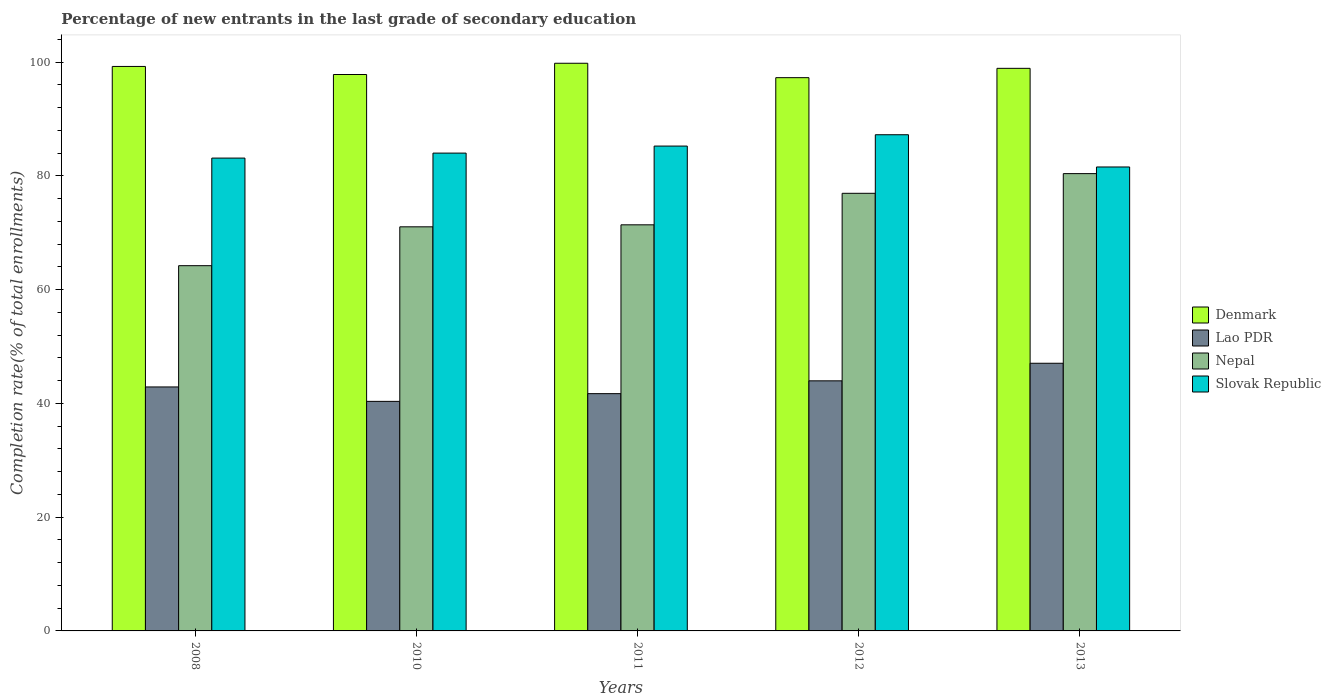How many groups of bars are there?
Make the answer very short. 5. Are the number of bars on each tick of the X-axis equal?
Provide a succinct answer. Yes. What is the label of the 4th group of bars from the left?
Make the answer very short. 2012. In how many cases, is the number of bars for a given year not equal to the number of legend labels?
Give a very brief answer. 0. What is the percentage of new entrants in Slovak Republic in 2010?
Ensure brevity in your answer.  84. Across all years, what is the maximum percentage of new entrants in Lao PDR?
Provide a succinct answer. 47.06. Across all years, what is the minimum percentage of new entrants in Denmark?
Your answer should be very brief. 97.26. In which year was the percentage of new entrants in Slovak Republic minimum?
Offer a terse response. 2013. What is the total percentage of new entrants in Lao PDR in the graph?
Offer a very short reply. 215.98. What is the difference between the percentage of new entrants in Lao PDR in 2012 and that in 2013?
Make the answer very short. -3.09. What is the difference between the percentage of new entrants in Nepal in 2011 and the percentage of new entrants in Slovak Republic in 2013?
Keep it short and to the point. -10.17. What is the average percentage of new entrants in Slovak Republic per year?
Your answer should be compact. 84.23. In the year 2010, what is the difference between the percentage of new entrants in Denmark and percentage of new entrants in Lao PDR?
Your answer should be very brief. 57.46. In how many years, is the percentage of new entrants in Lao PDR greater than 24 %?
Keep it short and to the point. 5. What is the ratio of the percentage of new entrants in Denmark in 2010 to that in 2012?
Make the answer very short. 1.01. Is the percentage of new entrants in Slovak Republic in 2010 less than that in 2011?
Your answer should be very brief. Yes. What is the difference between the highest and the second highest percentage of new entrants in Denmark?
Keep it short and to the point. 0.56. What is the difference between the highest and the lowest percentage of new entrants in Lao PDR?
Provide a short and direct response. 6.7. In how many years, is the percentage of new entrants in Nepal greater than the average percentage of new entrants in Nepal taken over all years?
Your response must be concise. 2. Is it the case that in every year, the sum of the percentage of new entrants in Nepal and percentage of new entrants in Denmark is greater than the sum of percentage of new entrants in Lao PDR and percentage of new entrants in Slovak Republic?
Ensure brevity in your answer.  Yes. What does the 4th bar from the left in 2011 represents?
Keep it short and to the point. Slovak Republic. What is the difference between two consecutive major ticks on the Y-axis?
Keep it short and to the point. 20. Does the graph contain any zero values?
Give a very brief answer. No. What is the title of the graph?
Your answer should be very brief. Percentage of new entrants in the last grade of secondary education. What is the label or title of the Y-axis?
Your answer should be compact. Completion rate(% of total enrollments). What is the Completion rate(% of total enrollments) in Denmark in 2008?
Ensure brevity in your answer.  99.23. What is the Completion rate(% of total enrollments) in Lao PDR in 2008?
Ensure brevity in your answer.  42.89. What is the Completion rate(% of total enrollments) of Nepal in 2008?
Offer a very short reply. 64.21. What is the Completion rate(% of total enrollments) in Slovak Republic in 2008?
Your response must be concise. 83.12. What is the Completion rate(% of total enrollments) in Denmark in 2010?
Your answer should be compact. 97.81. What is the Completion rate(% of total enrollments) of Lao PDR in 2010?
Offer a terse response. 40.36. What is the Completion rate(% of total enrollments) of Nepal in 2010?
Give a very brief answer. 71.04. What is the Completion rate(% of total enrollments) of Slovak Republic in 2010?
Your answer should be very brief. 84. What is the Completion rate(% of total enrollments) of Denmark in 2011?
Keep it short and to the point. 99.79. What is the Completion rate(% of total enrollments) of Lao PDR in 2011?
Provide a succinct answer. 41.71. What is the Completion rate(% of total enrollments) in Nepal in 2011?
Keep it short and to the point. 71.39. What is the Completion rate(% of total enrollments) of Slovak Republic in 2011?
Keep it short and to the point. 85.23. What is the Completion rate(% of total enrollments) of Denmark in 2012?
Your answer should be very brief. 97.26. What is the Completion rate(% of total enrollments) of Lao PDR in 2012?
Make the answer very short. 43.96. What is the Completion rate(% of total enrollments) in Nepal in 2012?
Give a very brief answer. 76.93. What is the Completion rate(% of total enrollments) of Slovak Republic in 2012?
Keep it short and to the point. 87.23. What is the Completion rate(% of total enrollments) of Denmark in 2013?
Make the answer very short. 98.9. What is the Completion rate(% of total enrollments) in Lao PDR in 2013?
Keep it short and to the point. 47.06. What is the Completion rate(% of total enrollments) in Nepal in 2013?
Your answer should be compact. 80.39. What is the Completion rate(% of total enrollments) in Slovak Republic in 2013?
Provide a short and direct response. 81.56. Across all years, what is the maximum Completion rate(% of total enrollments) of Denmark?
Your answer should be very brief. 99.79. Across all years, what is the maximum Completion rate(% of total enrollments) of Lao PDR?
Provide a succinct answer. 47.06. Across all years, what is the maximum Completion rate(% of total enrollments) in Nepal?
Provide a succinct answer. 80.39. Across all years, what is the maximum Completion rate(% of total enrollments) of Slovak Republic?
Your answer should be very brief. 87.23. Across all years, what is the minimum Completion rate(% of total enrollments) of Denmark?
Provide a succinct answer. 97.26. Across all years, what is the minimum Completion rate(% of total enrollments) of Lao PDR?
Provide a short and direct response. 40.36. Across all years, what is the minimum Completion rate(% of total enrollments) in Nepal?
Provide a succinct answer. 64.21. Across all years, what is the minimum Completion rate(% of total enrollments) of Slovak Republic?
Offer a terse response. 81.56. What is the total Completion rate(% of total enrollments) in Denmark in the graph?
Your answer should be compact. 493. What is the total Completion rate(% of total enrollments) of Lao PDR in the graph?
Provide a succinct answer. 215.98. What is the total Completion rate(% of total enrollments) of Nepal in the graph?
Ensure brevity in your answer.  363.96. What is the total Completion rate(% of total enrollments) in Slovak Republic in the graph?
Make the answer very short. 421.14. What is the difference between the Completion rate(% of total enrollments) in Denmark in 2008 and that in 2010?
Provide a succinct answer. 1.42. What is the difference between the Completion rate(% of total enrollments) of Lao PDR in 2008 and that in 2010?
Keep it short and to the point. 2.54. What is the difference between the Completion rate(% of total enrollments) in Nepal in 2008 and that in 2010?
Ensure brevity in your answer.  -6.83. What is the difference between the Completion rate(% of total enrollments) in Slovak Republic in 2008 and that in 2010?
Give a very brief answer. -0.88. What is the difference between the Completion rate(% of total enrollments) of Denmark in 2008 and that in 2011?
Ensure brevity in your answer.  -0.56. What is the difference between the Completion rate(% of total enrollments) in Lao PDR in 2008 and that in 2011?
Your response must be concise. 1.18. What is the difference between the Completion rate(% of total enrollments) of Nepal in 2008 and that in 2011?
Offer a very short reply. -7.18. What is the difference between the Completion rate(% of total enrollments) in Slovak Republic in 2008 and that in 2011?
Offer a terse response. -2.11. What is the difference between the Completion rate(% of total enrollments) in Denmark in 2008 and that in 2012?
Offer a terse response. 1.97. What is the difference between the Completion rate(% of total enrollments) of Lao PDR in 2008 and that in 2012?
Give a very brief answer. -1.07. What is the difference between the Completion rate(% of total enrollments) of Nepal in 2008 and that in 2012?
Offer a terse response. -12.72. What is the difference between the Completion rate(% of total enrollments) in Slovak Republic in 2008 and that in 2012?
Offer a terse response. -4.11. What is the difference between the Completion rate(% of total enrollments) in Denmark in 2008 and that in 2013?
Ensure brevity in your answer.  0.33. What is the difference between the Completion rate(% of total enrollments) of Lao PDR in 2008 and that in 2013?
Offer a terse response. -4.17. What is the difference between the Completion rate(% of total enrollments) of Nepal in 2008 and that in 2013?
Give a very brief answer. -16.19. What is the difference between the Completion rate(% of total enrollments) of Slovak Republic in 2008 and that in 2013?
Your response must be concise. 1.56. What is the difference between the Completion rate(% of total enrollments) of Denmark in 2010 and that in 2011?
Provide a short and direct response. -1.98. What is the difference between the Completion rate(% of total enrollments) in Lao PDR in 2010 and that in 2011?
Make the answer very short. -1.36. What is the difference between the Completion rate(% of total enrollments) in Nepal in 2010 and that in 2011?
Offer a very short reply. -0.35. What is the difference between the Completion rate(% of total enrollments) in Slovak Republic in 2010 and that in 2011?
Keep it short and to the point. -1.24. What is the difference between the Completion rate(% of total enrollments) of Denmark in 2010 and that in 2012?
Offer a very short reply. 0.55. What is the difference between the Completion rate(% of total enrollments) of Lao PDR in 2010 and that in 2012?
Give a very brief answer. -3.61. What is the difference between the Completion rate(% of total enrollments) in Nepal in 2010 and that in 2012?
Offer a very short reply. -5.89. What is the difference between the Completion rate(% of total enrollments) of Slovak Republic in 2010 and that in 2012?
Your answer should be very brief. -3.23. What is the difference between the Completion rate(% of total enrollments) of Denmark in 2010 and that in 2013?
Give a very brief answer. -1.09. What is the difference between the Completion rate(% of total enrollments) in Lao PDR in 2010 and that in 2013?
Keep it short and to the point. -6.7. What is the difference between the Completion rate(% of total enrollments) of Nepal in 2010 and that in 2013?
Offer a very short reply. -9.35. What is the difference between the Completion rate(% of total enrollments) of Slovak Republic in 2010 and that in 2013?
Your answer should be compact. 2.44. What is the difference between the Completion rate(% of total enrollments) in Denmark in 2011 and that in 2012?
Your response must be concise. 2.53. What is the difference between the Completion rate(% of total enrollments) in Lao PDR in 2011 and that in 2012?
Give a very brief answer. -2.25. What is the difference between the Completion rate(% of total enrollments) of Nepal in 2011 and that in 2012?
Offer a terse response. -5.54. What is the difference between the Completion rate(% of total enrollments) in Slovak Republic in 2011 and that in 2012?
Offer a very short reply. -1.99. What is the difference between the Completion rate(% of total enrollments) of Denmark in 2011 and that in 2013?
Give a very brief answer. 0.89. What is the difference between the Completion rate(% of total enrollments) of Lao PDR in 2011 and that in 2013?
Give a very brief answer. -5.34. What is the difference between the Completion rate(% of total enrollments) in Nepal in 2011 and that in 2013?
Your answer should be very brief. -9. What is the difference between the Completion rate(% of total enrollments) of Slovak Republic in 2011 and that in 2013?
Your answer should be compact. 3.67. What is the difference between the Completion rate(% of total enrollments) of Denmark in 2012 and that in 2013?
Your response must be concise. -1.64. What is the difference between the Completion rate(% of total enrollments) in Lao PDR in 2012 and that in 2013?
Offer a very short reply. -3.09. What is the difference between the Completion rate(% of total enrollments) of Nepal in 2012 and that in 2013?
Provide a succinct answer. -3.46. What is the difference between the Completion rate(% of total enrollments) of Slovak Republic in 2012 and that in 2013?
Your response must be concise. 5.67. What is the difference between the Completion rate(% of total enrollments) of Denmark in 2008 and the Completion rate(% of total enrollments) of Lao PDR in 2010?
Provide a short and direct response. 58.88. What is the difference between the Completion rate(% of total enrollments) in Denmark in 2008 and the Completion rate(% of total enrollments) in Nepal in 2010?
Keep it short and to the point. 28.19. What is the difference between the Completion rate(% of total enrollments) in Denmark in 2008 and the Completion rate(% of total enrollments) in Slovak Republic in 2010?
Your answer should be compact. 15.24. What is the difference between the Completion rate(% of total enrollments) in Lao PDR in 2008 and the Completion rate(% of total enrollments) in Nepal in 2010?
Keep it short and to the point. -28.15. What is the difference between the Completion rate(% of total enrollments) in Lao PDR in 2008 and the Completion rate(% of total enrollments) in Slovak Republic in 2010?
Your answer should be very brief. -41.11. What is the difference between the Completion rate(% of total enrollments) of Nepal in 2008 and the Completion rate(% of total enrollments) of Slovak Republic in 2010?
Provide a short and direct response. -19.79. What is the difference between the Completion rate(% of total enrollments) of Denmark in 2008 and the Completion rate(% of total enrollments) of Lao PDR in 2011?
Your response must be concise. 57.52. What is the difference between the Completion rate(% of total enrollments) of Denmark in 2008 and the Completion rate(% of total enrollments) of Nepal in 2011?
Give a very brief answer. 27.84. What is the difference between the Completion rate(% of total enrollments) in Denmark in 2008 and the Completion rate(% of total enrollments) in Slovak Republic in 2011?
Keep it short and to the point. 14. What is the difference between the Completion rate(% of total enrollments) of Lao PDR in 2008 and the Completion rate(% of total enrollments) of Nepal in 2011?
Provide a succinct answer. -28.5. What is the difference between the Completion rate(% of total enrollments) of Lao PDR in 2008 and the Completion rate(% of total enrollments) of Slovak Republic in 2011?
Make the answer very short. -42.34. What is the difference between the Completion rate(% of total enrollments) of Nepal in 2008 and the Completion rate(% of total enrollments) of Slovak Republic in 2011?
Give a very brief answer. -21.03. What is the difference between the Completion rate(% of total enrollments) of Denmark in 2008 and the Completion rate(% of total enrollments) of Lao PDR in 2012?
Make the answer very short. 55.27. What is the difference between the Completion rate(% of total enrollments) of Denmark in 2008 and the Completion rate(% of total enrollments) of Nepal in 2012?
Give a very brief answer. 22.3. What is the difference between the Completion rate(% of total enrollments) in Denmark in 2008 and the Completion rate(% of total enrollments) in Slovak Republic in 2012?
Offer a very short reply. 12.01. What is the difference between the Completion rate(% of total enrollments) of Lao PDR in 2008 and the Completion rate(% of total enrollments) of Nepal in 2012?
Offer a very short reply. -34.04. What is the difference between the Completion rate(% of total enrollments) of Lao PDR in 2008 and the Completion rate(% of total enrollments) of Slovak Republic in 2012?
Ensure brevity in your answer.  -44.34. What is the difference between the Completion rate(% of total enrollments) in Nepal in 2008 and the Completion rate(% of total enrollments) in Slovak Republic in 2012?
Give a very brief answer. -23.02. What is the difference between the Completion rate(% of total enrollments) in Denmark in 2008 and the Completion rate(% of total enrollments) in Lao PDR in 2013?
Offer a very short reply. 52.18. What is the difference between the Completion rate(% of total enrollments) of Denmark in 2008 and the Completion rate(% of total enrollments) of Nepal in 2013?
Provide a succinct answer. 18.84. What is the difference between the Completion rate(% of total enrollments) in Denmark in 2008 and the Completion rate(% of total enrollments) in Slovak Republic in 2013?
Offer a very short reply. 17.67. What is the difference between the Completion rate(% of total enrollments) of Lao PDR in 2008 and the Completion rate(% of total enrollments) of Nepal in 2013?
Your response must be concise. -37.5. What is the difference between the Completion rate(% of total enrollments) of Lao PDR in 2008 and the Completion rate(% of total enrollments) of Slovak Republic in 2013?
Make the answer very short. -38.67. What is the difference between the Completion rate(% of total enrollments) in Nepal in 2008 and the Completion rate(% of total enrollments) in Slovak Republic in 2013?
Offer a very short reply. -17.35. What is the difference between the Completion rate(% of total enrollments) of Denmark in 2010 and the Completion rate(% of total enrollments) of Lao PDR in 2011?
Provide a short and direct response. 56.1. What is the difference between the Completion rate(% of total enrollments) of Denmark in 2010 and the Completion rate(% of total enrollments) of Nepal in 2011?
Your answer should be compact. 26.42. What is the difference between the Completion rate(% of total enrollments) in Denmark in 2010 and the Completion rate(% of total enrollments) in Slovak Republic in 2011?
Offer a very short reply. 12.58. What is the difference between the Completion rate(% of total enrollments) in Lao PDR in 2010 and the Completion rate(% of total enrollments) in Nepal in 2011?
Offer a terse response. -31.04. What is the difference between the Completion rate(% of total enrollments) of Lao PDR in 2010 and the Completion rate(% of total enrollments) of Slovak Republic in 2011?
Keep it short and to the point. -44.88. What is the difference between the Completion rate(% of total enrollments) of Nepal in 2010 and the Completion rate(% of total enrollments) of Slovak Republic in 2011?
Provide a short and direct response. -14.19. What is the difference between the Completion rate(% of total enrollments) of Denmark in 2010 and the Completion rate(% of total enrollments) of Lao PDR in 2012?
Offer a terse response. 53.85. What is the difference between the Completion rate(% of total enrollments) in Denmark in 2010 and the Completion rate(% of total enrollments) in Nepal in 2012?
Keep it short and to the point. 20.88. What is the difference between the Completion rate(% of total enrollments) of Denmark in 2010 and the Completion rate(% of total enrollments) of Slovak Republic in 2012?
Your answer should be very brief. 10.59. What is the difference between the Completion rate(% of total enrollments) of Lao PDR in 2010 and the Completion rate(% of total enrollments) of Nepal in 2012?
Your answer should be compact. -36.58. What is the difference between the Completion rate(% of total enrollments) of Lao PDR in 2010 and the Completion rate(% of total enrollments) of Slovak Republic in 2012?
Your answer should be compact. -46.87. What is the difference between the Completion rate(% of total enrollments) of Nepal in 2010 and the Completion rate(% of total enrollments) of Slovak Republic in 2012?
Provide a short and direct response. -16.19. What is the difference between the Completion rate(% of total enrollments) of Denmark in 2010 and the Completion rate(% of total enrollments) of Lao PDR in 2013?
Your answer should be compact. 50.76. What is the difference between the Completion rate(% of total enrollments) in Denmark in 2010 and the Completion rate(% of total enrollments) in Nepal in 2013?
Offer a very short reply. 17.42. What is the difference between the Completion rate(% of total enrollments) in Denmark in 2010 and the Completion rate(% of total enrollments) in Slovak Republic in 2013?
Provide a succinct answer. 16.26. What is the difference between the Completion rate(% of total enrollments) in Lao PDR in 2010 and the Completion rate(% of total enrollments) in Nepal in 2013?
Provide a short and direct response. -40.04. What is the difference between the Completion rate(% of total enrollments) in Lao PDR in 2010 and the Completion rate(% of total enrollments) in Slovak Republic in 2013?
Offer a terse response. -41.2. What is the difference between the Completion rate(% of total enrollments) in Nepal in 2010 and the Completion rate(% of total enrollments) in Slovak Republic in 2013?
Offer a terse response. -10.52. What is the difference between the Completion rate(% of total enrollments) in Denmark in 2011 and the Completion rate(% of total enrollments) in Lao PDR in 2012?
Your response must be concise. 55.83. What is the difference between the Completion rate(% of total enrollments) of Denmark in 2011 and the Completion rate(% of total enrollments) of Nepal in 2012?
Offer a terse response. 22.86. What is the difference between the Completion rate(% of total enrollments) in Denmark in 2011 and the Completion rate(% of total enrollments) in Slovak Republic in 2012?
Your answer should be very brief. 12.57. What is the difference between the Completion rate(% of total enrollments) of Lao PDR in 2011 and the Completion rate(% of total enrollments) of Nepal in 2012?
Ensure brevity in your answer.  -35.22. What is the difference between the Completion rate(% of total enrollments) of Lao PDR in 2011 and the Completion rate(% of total enrollments) of Slovak Republic in 2012?
Provide a succinct answer. -45.52. What is the difference between the Completion rate(% of total enrollments) of Nepal in 2011 and the Completion rate(% of total enrollments) of Slovak Republic in 2012?
Keep it short and to the point. -15.84. What is the difference between the Completion rate(% of total enrollments) in Denmark in 2011 and the Completion rate(% of total enrollments) in Lao PDR in 2013?
Provide a succinct answer. 52.74. What is the difference between the Completion rate(% of total enrollments) of Denmark in 2011 and the Completion rate(% of total enrollments) of Nepal in 2013?
Your answer should be compact. 19.4. What is the difference between the Completion rate(% of total enrollments) of Denmark in 2011 and the Completion rate(% of total enrollments) of Slovak Republic in 2013?
Offer a very short reply. 18.23. What is the difference between the Completion rate(% of total enrollments) of Lao PDR in 2011 and the Completion rate(% of total enrollments) of Nepal in 2013?
Offer a very short reply. -38.68. What is the difference between the Completion rate(% of total enrollments) in Lao PDR in 2011 and the Completion rate(% of total enrollments) in Slovak Republic in 2013?
Your answer should be very brief. -39.85. What is the difference between the Completion rate(% of total enrollments) of Nepal in 2011 and the Completion rate(% of total enrollments) of Slovak Republic in 2013?
Offer a terse response. -10.17. What is the difference between the Completion rate(% of total enrollments) of Denmark in 2012 and the Completion rate(% of total enrollments) of Lao PDR in 2013?
Offer a terse response. 50.2. What is the difference between the Completion rate(% of total enrollments) of Denmark in 2012 and the Completion rate(% of total enrollments) of Nepal in 2013?
Offer a terse response. 16.87. What is the difference between the Completion rate(% of total enrollments) of Denmark in 2012 and the Completion rate(% of total enrollments) of Slovak Republic in 2013?
Give a very brief answer. 15.7. What is the difference between the Completion rate(% of total enrollments) of Lao PDR in 2012 and the Completion rate(% of total enrollments) of Nepal in 2013?
Your answer should be compact. -36.43. What is the difference between the Completion rate(% of total enrollments) in Lao PDR in 2012 and the Completion rate(% of total enrollments) in Slovak Republic in 2013?
Your answer should be very brief. -37.6. What is the difference between the Completion rate(% of total enrollments) of Nepal in 2012 and the Completion rate(% of total enrollments) of Slovak Republic in 2013?
Your answer should be very brief. -4.63. What is the average Completion rate(% of total enrollments) of Denmark per year?
Keep it short and to the point. 98.6. What is the average Completion rate(% of total enrollments) of Lao PDR per year?
Your answer should be very brief. 43.2. What is the average Completion rate(% of total enrollments) of Nepal per year?
Offer a terse response. 72.79. What is the average Completion rate(% of total enrollments) of Slovak Republic per year?
Give a very brief answer. 84.23. In the year 2008, what is the difference between the Completion rate(% of total enrollments) of Denmark and Completion rate(% of total enrollments) of Lao PDR?
Keep it short and to the point. 56.34. In the year 2008, what is the difference between the Completion rate(% of total enrollments) in Denmark and Completion rate(% of total enrollments) in Nepal?
Offer a very short reply. 35.03. In the year 2008, what is the difference between the Completion rate(% of total enrollments) in Denmark and Completion rate(% of total enrollments) in Slovak Republic?
Provide a succinct answer. 16.11. In the year 2008, what is the difference between the Completion rate(% of total enrollments) in Lao PDR and Completion rate(% of total enrollments) in Nepal?
Ensure brevity in your answer.  -21.32. In the year 2008, what is the difference between the Completion rate(% of total enrollments) in Lao PDR and Completion rate(% of total enrollments) in Slovak Republic?
Your answer should be very brief. -40.23. In the year 2008, what is the difference between the Completion rate(% of total enrollments) in Nepal and Completion rate(% of total enrollments) in Slovak Republic?
Provide a succinct answer. -18.92. In the year 2010, what is the difference between the Completion rate(% of total enrollments) of Denmark and Completion rate(% of total enrollments) of Lao PDR?
Provide a succinct answer. 57.46. In the year 2010, what is the difference between the Completion rate(% of total enrollments) in Denmark and Completion rate(% of total enrollments) in Nepal?
Ensure brevity in your answer.  26.77. In the year 2010, what is the difference between the Completion rate(% of total enrollments) of Denmark and Completion rate(% of total enrollments) of Slovak Republic?
Your response must be concise. 13.82. In the year 2010, what is the difference between the Completion rate(% of total enrollments) in Lao PDR and Completion rate(% of total enrollments) in Nepal?
Your answer should be very brief. -30.69. In the year 2010, what is the difference between the Completion rate(% of total enrollments) in Lao PDR and Completion rate(% of total enrollments) in Slovak Republic?
Offer a very short reply. -43.64. In the year 2010, what is the difference between the Completion rate(% of total enrollments) in Nepal and Completion rate(% of total enrollments) in Slovak Republic?
Ensure brevity in your answer.  -12.96. In the year 2011, what is the difference between the Completion rate(% of total enrollments) in Denmark and Completion rate(% of total enrollments) in Lao PDR?
Provide a short and direct response. 58.08. In the year 2011, what is the difference between the Completion rate(% of total enrollments) of Denmark and Completion rate(% of total enrollments) of Nepal?
Offer a very short reply. 28.4. In the year 2011, what is the difference between the Completion rate(% of total enrollments) in Denmark and Completion rate(% of total enrollments) in Slovak Republic?
Offer a very short reply. 14.56. In the year 2011, what is the difference between the Completion rate(% of total enrollments) of Lao PDR and Completion rate(% of total enrollments) of Nepal?
Ensure brevity in your answer.  -29.68. In the year 2011, what is the difference between the Completion rate(% of total enrollments) of Lao PDR and Completion rate(% of total enrollments) of Slovak Republic?
Provide a succinct answer. -43.52. In the year 2011, what is the difference between the Completion rate(% of total enrollments) in Nepal and Completion rate(% of total enrollments) in Slovak Republic?
Keep it short and to the point. -13.84. In the year 2012, what is the difference between the Completion rate(% of total enrollments) in Denmark and Completion rate(% of total enrollments) in Lao PDR?
Your answer should be very brief. 53.3. In the year 2012, what is the difference between the Completion rate(% of total enrollments) in Denmark and Completion rate(% of total enrollments) in Nepal?
Keep it short and to the point. 20.33. In the year 2012, what is the difference between the Completion rate(% of total enrollments) of Denmark and Completion rate(% of total enrollments) of Slovak Republic?
Provide a succinct answer. 10.03. In the year 2012, what is the difference between the Completion rate(% of total enrollments) in Lao PDR and Completion rate(% of total enrollments) in Nepal?
Make the answer very short. -32.97. In the year 2012, what is the difference between the Completion rate(% of total enrollments) in Lao PDR and Completion rate(% of total enrollments) in Slovak Republic?
Offer a very short reply. -43.26. In the year 2012, what is the difference between the Completion rate(% of total enrollments) in Nepal and Completion rate(% of total enrollments) in Slovak Republic?
Your response must be concise. -10.3. In the year 2013, what is the difference between the Completion rate(% of total enrollments) in Denmark and Completion rate(% of total enrollments) in Lao PDR?
Give a very brief answer. 51.85. In the year 2013, what is the difference between the Completion rate(% of total enrollments) of Denmark and Completion rate(% of total enrollments) of Nepal?
Your answer should be compact. 18.51. In the year 2013, what is the difference between the Completion rate(% of total enrollments) of Denmark and Completion rate(% of total enrollments) of Slovak Republic?
Your answer should be compact. 17.34. In the year 2013, what is the difference between the Completion rate(% of total enrollments) in Lao PDR and Completion rate(% of total enrollments) in Nepal?
Make the answer very short. -33.34. In the year 2013, what is the difference between the Completion rate(% of total enrollments) in Lao PDR and Completion rate(% of total enrollments) in Slovak Republic?
Your response must be concise. -34.5. In the year 2013, what is the difference between the Completion rate(% of total enrollments) in Nepal and Completion rate(% of total enrollments) in Slovak Republic?
Ensure brevity in your answer.  -1.17. What is the ratio of the Completion rate(% of total enrollments) in Denmark in 2008 to that in 2010?
Your response must be concise. 1.01. What is the ratio of the Completion rate(% of total enrollments) in Lao PDR in 2008 to that in 2010?
Ensure brevity in your answer.  1.06. What is the ratio of the Completion rate(% of total enrollments) of Nepal in 2008 to that in 2010?
Ensure brevity in your answer.  0.9. What is the ratio of the Completion rate(% of total enrollments) of Slovak Republic in 2008 to that in 2010?
Your answer should be compact. 0.99. What is the ratio of the Completion rate(% of total enrollments) in Lao PDR in 2008 to that in 2011?
Provide a short and direct response. 1.03. What is the ratio of the Completion rate(% of total enrollments) in Nepal in 2008 to that in 2011?
Ensure brevity in your answer.  0.9. What is the ratio of the Completion rate(% of total enrollments) of Slovak Republic in 2008 to that in 2011?
Offer a terse response. 0.98. What is the ratio of the Completion rate(% of total enrollments) of Denmark in 2008 to that in 2012?
Keep it short and to the point. 1.02. What is the ratio of the Completion rate(% of total enrollments) in Lao PDR in 2008 to that in 2012?
Your answer should be compact. 0.98. What is the ratio of the Completion rate(% of total enrollments) in Nepal in 2008 to that in 2012?
Provide a succinct answer. 0.83. What is the ratio of the Completion rate(% of total enrollments) in Slovak Republic in 2008 to that in 2012?
Offer a terse response. 0.95. What is the ratio of the Completion rate(% of total enrollments) of Lao PDR in 2008 to that in 2013?
Give a very brief answer. 0.91. What is the ratio of the Completion rate(% of total enrollments) in Nepal in 2008 to that in 2013?
Give a very brief answer. 0.8. What is the ratio of the Completion rate(% of total enrollments) of Slovak Republic in 2008 to that in 2013?
Provide a succinct answer. 1.02. What is the ratio of the Completion rate(% of total enrollments) of Denmark in 2010 to that in 2011?
Provide a succinct answer. 0.98. What is the ratio of the Completion rate(% of total enrollments) of Lao PDR in 2010 to that in 2011?
Your answer should be compact. 0.97. What is the ratio of the Completion rate(% of total enrollments) in Nepal in 2010 to that in 2011?
Keep it short and to the point. 1. What is the ratio of the Completion rate(% of total enrollments) in Slovak Republic in 2010 to that in 2011?
Your response must be concise. 0.99. What is the ratio of the Completion rate(% of total enrollments) of Lao PDR in 2010 to that in 2012?
Give a very brief answer. 0.92. What is the ratio of the Completion rate(% of total enrollments) in Nepal in 2010 to that in 2012?
Offer a terse response. 0.92. What is the ratio of the Completion rate(% of total enrollments) of Slovak Republic in 2010 to that in 2012?
Give a very brief answer. 0.96. What is the ratio of the Completion rate(% of total enrollments) in Denmark in 2010 to that in 2013?
Give a very brief answer. 0.99. What is the ratio of the Completion rate(% of total enrollments) of Lao PDR in 2010 to that in 2013?
Give a very brief answer. 0.86. What is the ratio of the Completion rate(% of total enrollments) in Nepal in 2010 to that in 2013?
Keep it short and to the point. 0.88. What is the ratio of the Completion rate(% of total enrollments) in Slovak Republic in 2010 to that in 2013?
Offer a terse response. 1.03. What is the ratio of the Completion rate(% of total enrollments) of Lao PDR in 2011 to that in 2012?
Ensure brevity in your answer.  0.95. What is the ratio of the Completion rate(% of total enrollments) of Nepal in 2011 to that in 2012?
Give a very brief answer. 0.93. What is the ratio of the Completion rate(% of total enrollments) of Slovak Republic in 2011 to that in 2012?
Give a very brief answer. 0.98. What is the ratio of the Completion rate(% of total enrollments) of Denmark in 2011 to that in 2013?
Give a very brief answer. 1.01. What is the ratio of the Completion rate(% of total enrollments) in Lao PDR in 2011 to that in 2013?
Provide a succinct answer. 0.89. What is the ratio of the Completion rate(% of total enrollments) of Nepal in 2011 to that in 2013?
Make the answer very short. 0.89. What is the ratio of the Completion rate(% of total enrollments) of Slovak Republic in 2011 to that in 2013?
Make the answer very short. 1.05. What is the ratio of the Completion rate(% of total enrollments) in Denmark in 2012 to that in 2013?
Make the answer very short. 0.98. What is the ratio of the Completion rate(% of total enrollments) of Lao PDR in 2012 to that in 2013?
Your response must be concise. 0.93. What is the ratio of the Completion rate(% of total enrollments) of Nepal in 2012 to that in 2013?
Give a very brief answer. 0.96. What is the ratio of the Completion rate(% of total enrollments) in Slovak Republic in 2012 to that in 2013?
Keep it short and to the point. 1.07. What is the difference between the highest and the second highest Completion rate(% of total enrollments) of Denmark?
Offer a terse response. 0.56. What is the difference between the highest and the second highest Completion rate(% of total enrollments) in Lao PDR?
Offer a terse response. 3.09. What is the difference between the highest and the second highest Completion rate(% of total enrollments) of Nepal?
Give a very brief answer. 3.46. What is the difference between the highest and the second highest Completion rate(% of total enrollments) of Slovak Republic?
Offer a terse response. 1.99. What is the difference between the highest and the lowest Completion rate(% of total enrollments) of Denmark?
Keep it short and to the point. 2.53. What is the difference between the highest and the lowest Completion rate(% of total enrollments) in Lao PDR?
Ensure brevity in your answer.  6.7. What is the difference between the highest and the lowest Completion rate(% of total enrollments) in Nepal?
Your answer should be compact. 16.19. What is the difference between the highest and the lowest Completion rate(% of total enrollments) of Slovak Republic?
Provide a short and direct response. 5.67. 